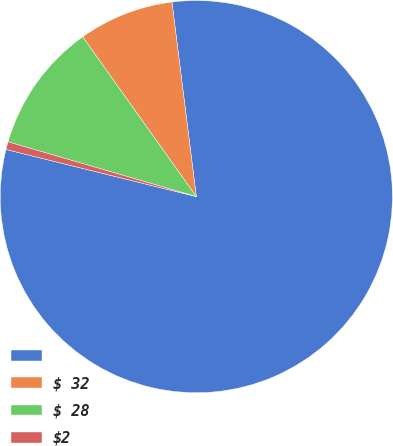<chart> <loc_0><loc_0><loc_500><loc_500><pie_chart><ecel><fcel>$ 32<fcel>$ 28<fcel>$2<nl><fcel>80.85%<fcel>7.86%<fcel>10.65%<fcel>0.64%<nl></chart> 